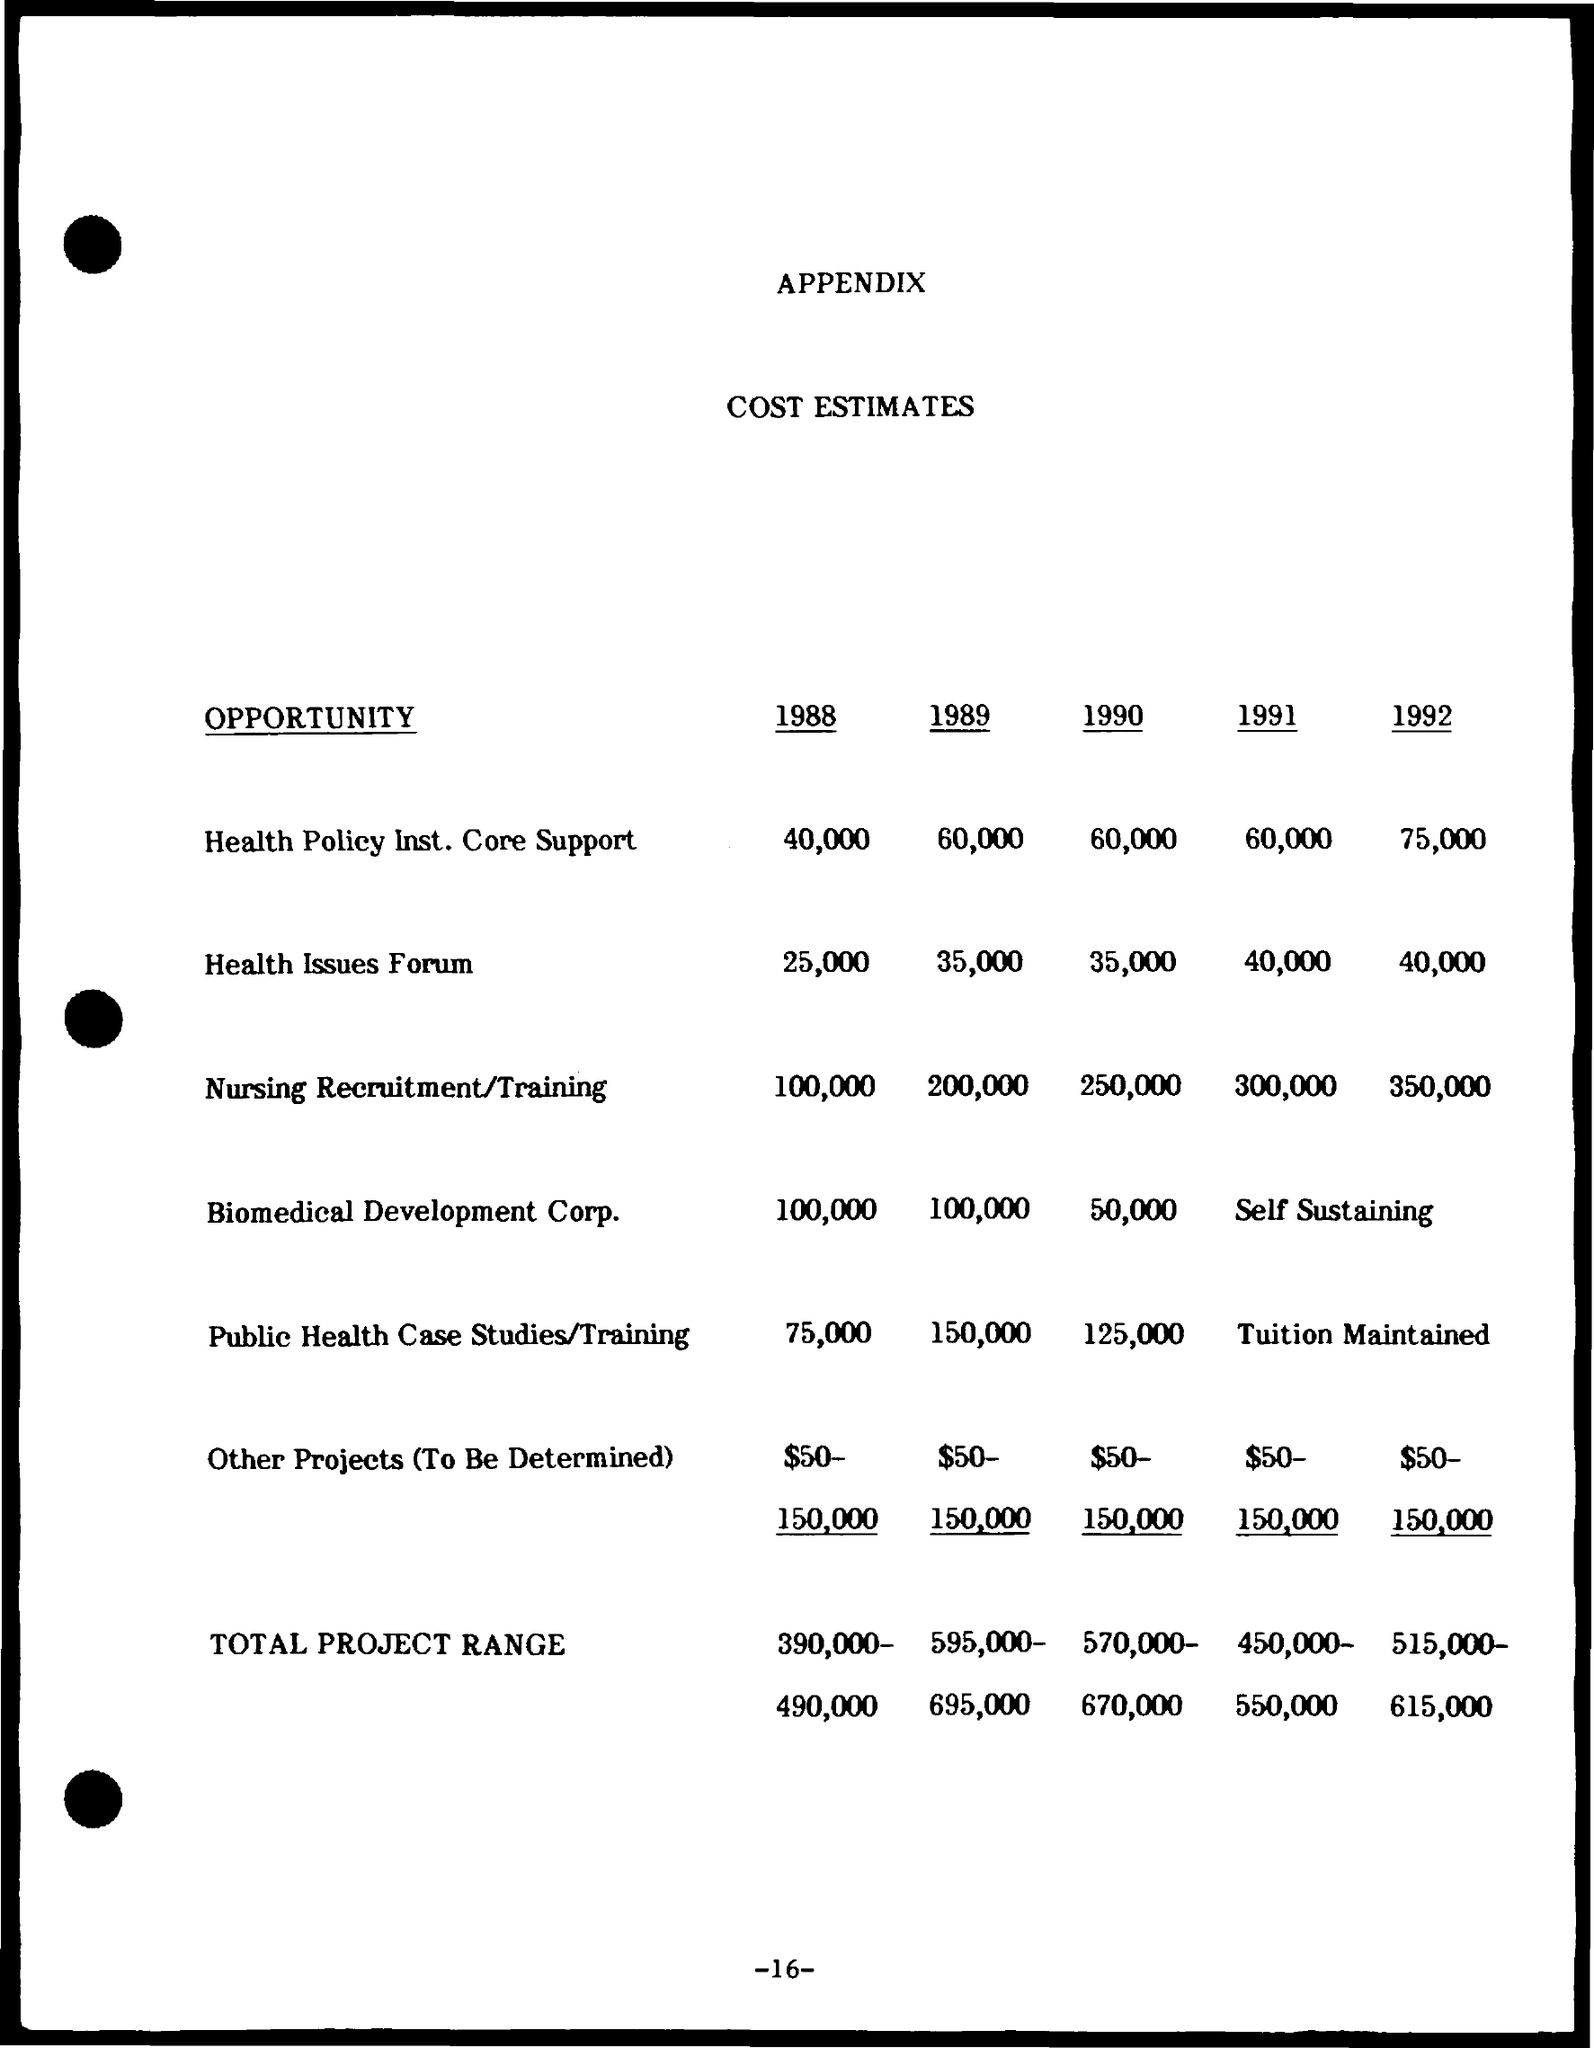Specify some key components in this picture. The cost estimate for Biomedical Development Corp. for 1989 was $100,000. The estimated cost for public health case studies/training in 1988 is 75,000. The cost estimate for Health Policy Ins. Core Support for the year 1989 is approximately 60,000. The cost estimate for Health Policy Insurance Core Support in 1988 is $40,000. The cost estimate for public health case studies and training in 1989 was 150,000. 